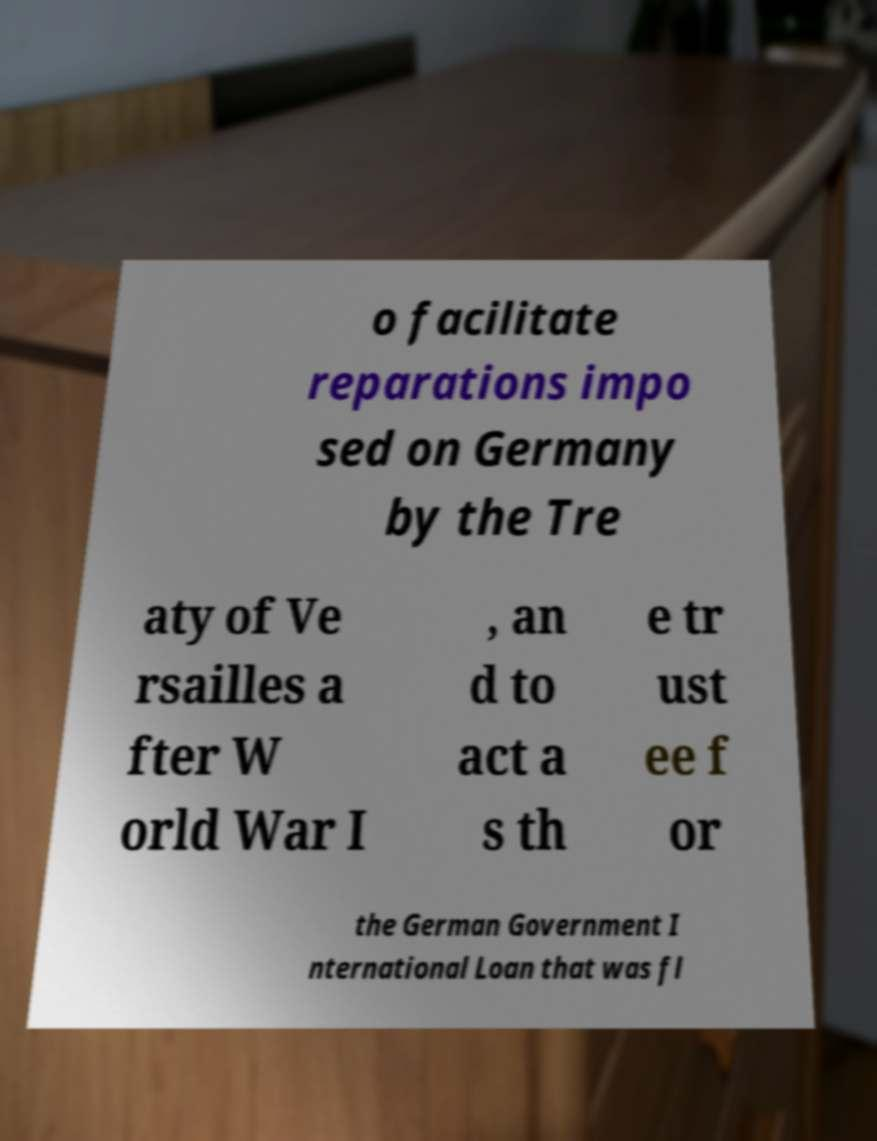Can you read and provide the text displayed in the image?This photo seems to have some interesting text. Can you extract and type it out for me? o facilitate reparations impo sed on Germany by the Tre aty of Ve rsailles a fter W orld War I , an d to act a s th e tr ust ee f or the German Government I nternational Loan that was fl 